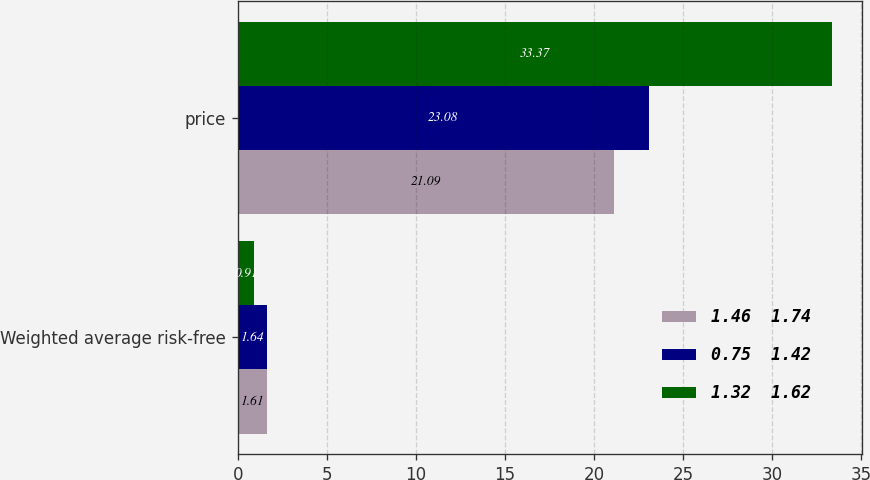<chart> <loc_0><loc_0><loc_500><loc_500><stacked_bar_chart><ecel><fcel>Weighted average risk-free<fcel>price<nl><fcel>1.46  1.74<fcel>1.61<fcel>21.09<nl><fcel>0.75  1.42<fcel>1.64<fcel>23.08<nl><fcel>1.32  1.62<fcel>0.91<fcel>33.37<nl></chart> 